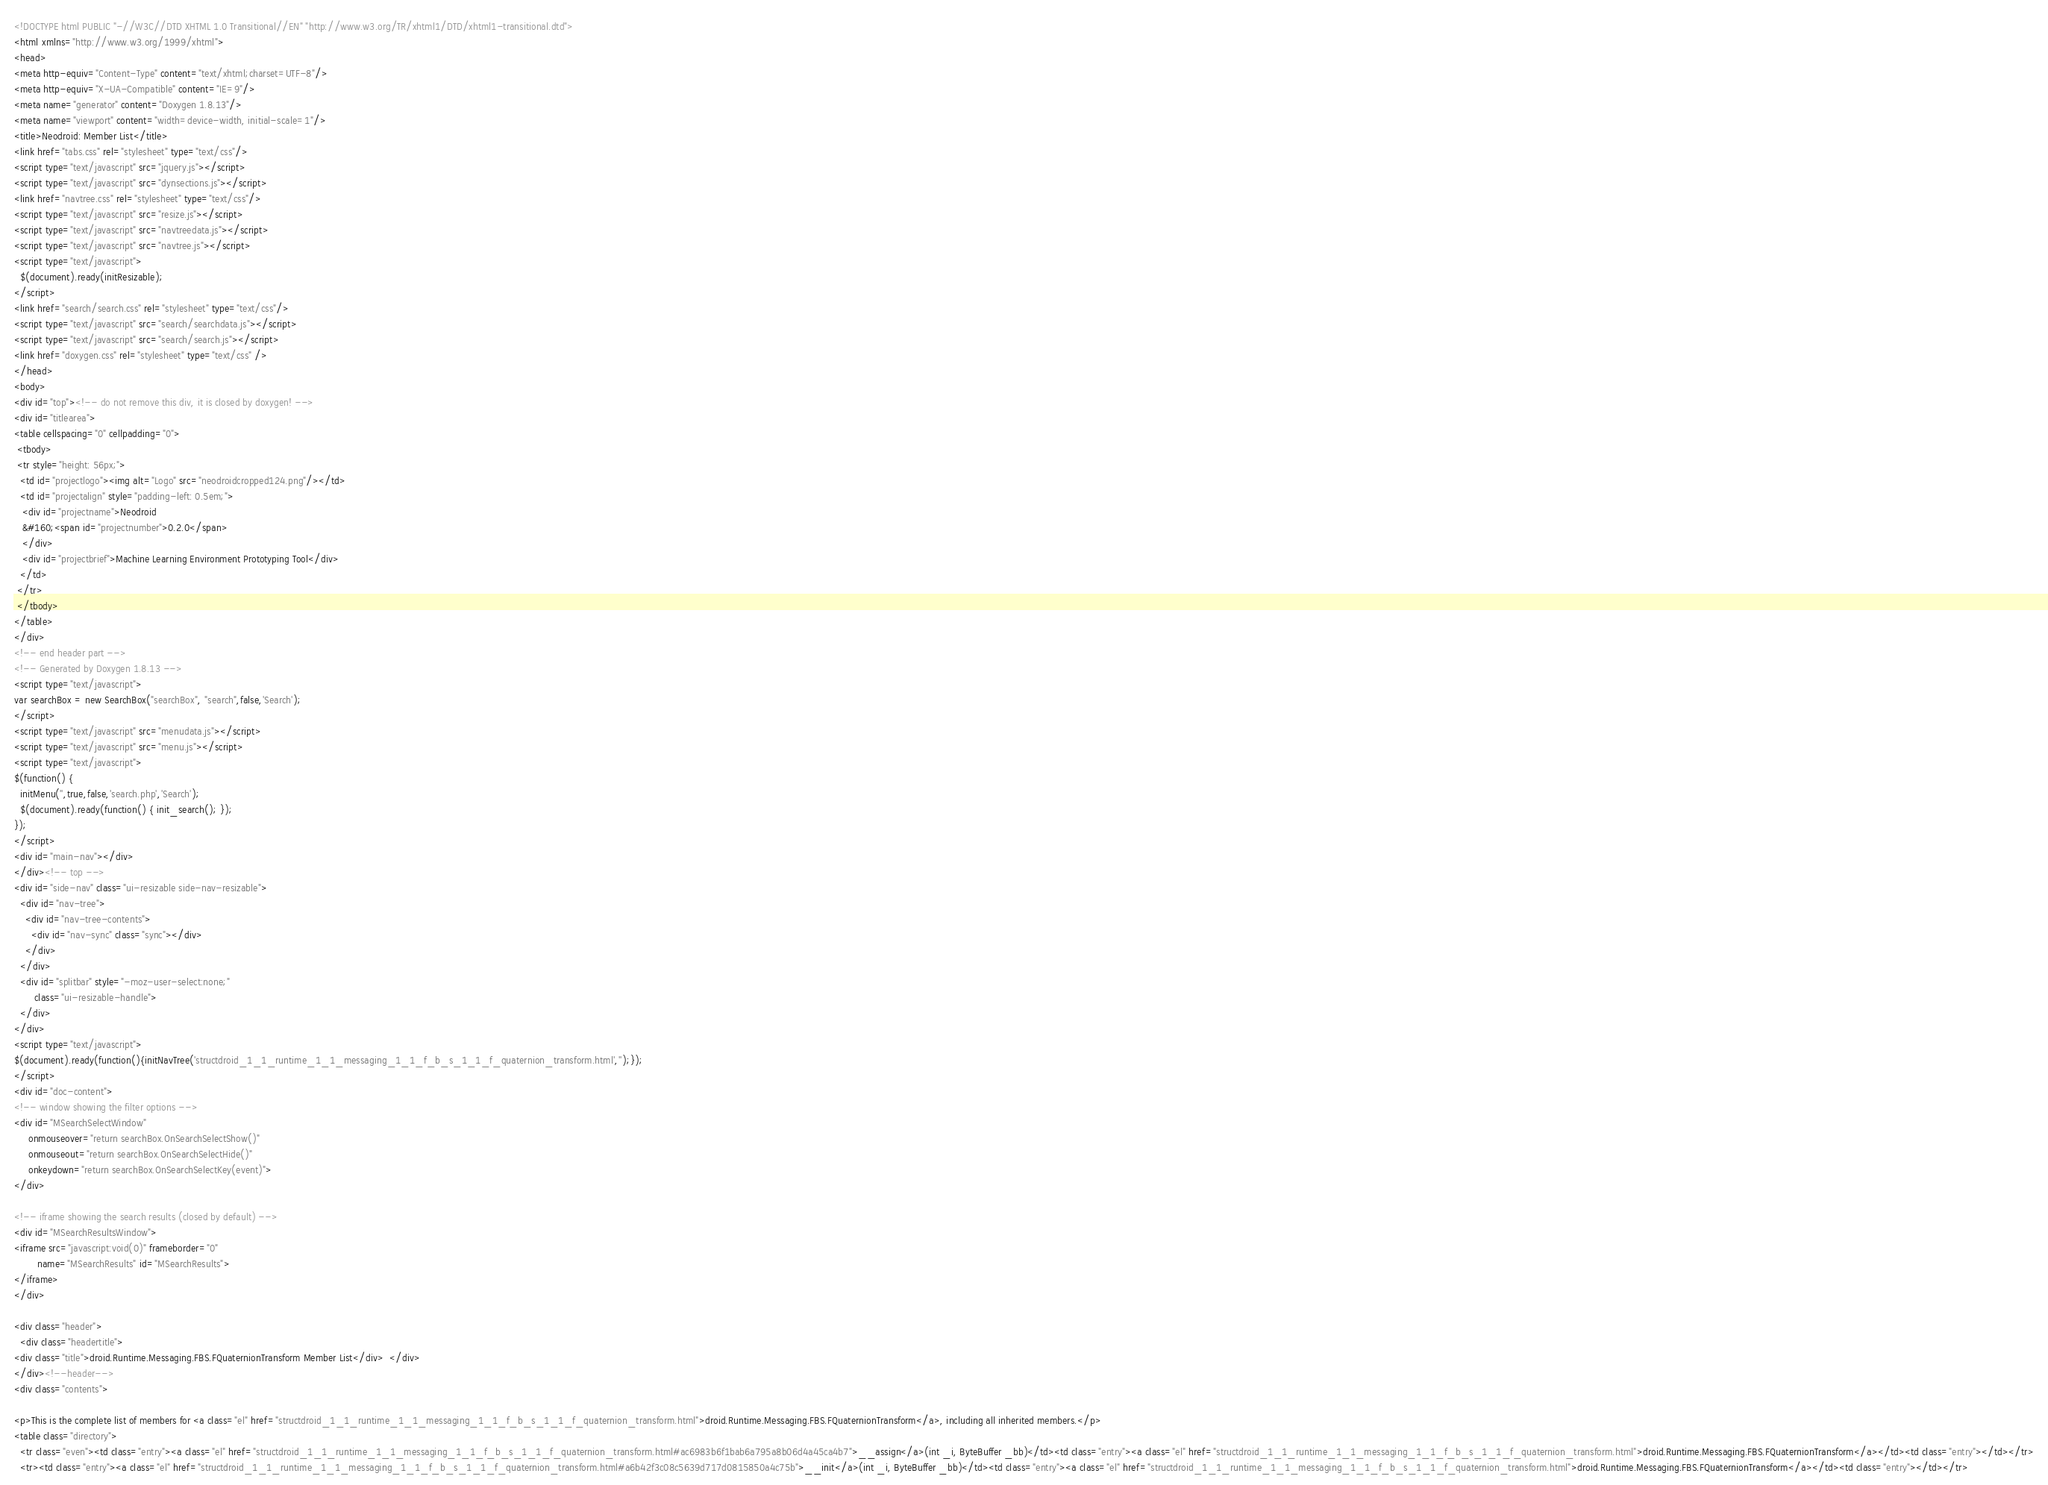Convert code to text. <code><loc_0><loc_0><loc_500><loc_500><_HTML_><!DOCTYPE html PUBLIC "-//W3C//DTD XHTML 1.0 Transitional//EN" "http://www.w3.org/TR/xhtml1/DTD/xhtml1-transitional.dtd">
<html xmlns="http://www.w3.org/1999/xhtml">
<head>
<meta http-equiv="Content-Type" content="text/xhtml;charset=UTF-8"/>
<meta http-equiv="X-UA-Compatible" content="IE=9"/>
<meta name="generator" content="Doxygen 1.8.13"/>
<meta name="viewport" content="width=device-width, initial-scale=1"/>
<title>Neodroid: Member List</title>
<link href="tabs.css" rel="stylesheet" type="text/css"/>
<script type="text/javascript" src="jquery.js"></script>
<script type="text/javascript" src="dynsections.js"></script>
<link href="navtree.css" rel="stylesheet" type="text/css"/>
<script type="text/javascript" src="resize.js"></script>
<script type="text/javascript" src="navtreedata.js"></script>
<script type="text/javascript" src="navtree.js"></script>
<script type="text/javascript">
  $(document).ready(initResizable);
</script>
<link href="search/search.css" rel="stylesheet" type="text/css"/>
<script type="text/javascript" src="search/searchdata.js"></script>
<script type="text/javascript" src="search/search.js"></script>
<link href="doxygen.css" rel="stylesheet" type="text/css" />
</head>
<body>
<div id="top"><!-- do not remove this div, it is closed by doxygen! -->
<div id="titlearea">
<table cellspacing="0" cellpadding="0">
 <tbody>
 <tr style="height: 56px;">
  <td id="projectlogo"><img alt="Logo" src="neodroidcropped124.png"/></td>
  <td id="projectalign" style="padding-left: 0.5em;">
   <div id="projectname">Neodroid
   &#160;<span id="projectnumber">0.2.0</span>
   </div>
   <div id="projectbrief">Machine Learning Environment Prototyping Tool</div>
  </td>
 </tr>
 </tbody>
</table>
</div>
<!-- end header part -->
<!-- Generated by Doxygen 1.8.13 -->
<script type="text/javascript">
var searchBox = new SearchBox("searchBox", "search",false,'Search');
</script>
<script type="text/javascript" src="menudata.js"></script>
<script type="text/javascript" src="menu.js"></script>
<script type="text/javascript">
$(function() {
  initMenu('',true,false,'search.php','Search');
  $(document).ready(function() { init_search(); });
});
</script>
<div id="main-nav"></div>
</div><!-- top -->
<div id="side-nav" class="ui-resizable side-nav-resizable">
  <div id="nav-tree">
    <div id="nav-tree-contents">
      <div id="nav-sync" class="sync"></div>
    </div>
  </div>
  <div id="splitbar" style="-moz-user-select:none;" 
       class="ui-resizable-handle">
  </div>
</div>
<script type="text/javascript">
$(document).ready(function(){initNavTree('structdroid_1_1_runtime_1_1_messaging_1_1_f_b_s_1_1_f_quaternion_transform.html','');});
</script>
<div id="doc-content">
<!-- window showing the filter options -->
<div id="MSearchSelectWindow"
     onmouseover="return searchBox.OnSearchSelectShow()"
     onmouseout="return searchBox.OnSearchSelectHide()"
     onkeydown="return searchBox.OnSearchSelectKey(event)">
</div>

<!-- iframe showing the search results (closed by default) -->
<div id="MSearchResultsWindow">
<iframe src="javascript:void(0)" frameborder="0" 
        name="MSearchResults" id="MSearchResults">
</iframe>
</div>

<div class="header">
  <div class="headertitle">
<div class="title">droid.Runtime.Messaging.FBS.FQuaternionTransform Member List</div>  </div>
</div><!--header-->
<div class="contents">

<p>This is the complete list of members for <a class="el" href="structdroid_1_1_runtime_1_1_messaging_1_1_f_b_s_1_1_f_quaternion_transform.html">droid.Runtime.Messaging.FBS.FQuaternionTransform</a>, including all inherited members.</p>
<table class="directory">
  <tr class="even"><td class="entry"><a class="el" href="structdroid_1_1_runtime_1_1_messaging_1_1_f_b_s_1_1_f_quaternion_transform.html#ac6983b6f1bab6a795a8b06d4a45ca4b7">__assign</a>(int _i, ByteBuffer _bb)</td><td class="entry"><a class="el" href="structdroid_1_1_runtime_1_1_messaging_1_1_f_b_s_1_1_f_quaternion_transform.html">droid.Runtime.Messaging.FBS.FQuaternionTransform</a></td><td class="entry"></td></tr>
  <tr><td class="entry"><a class="el" href="structdroid_1_1_runtime_1_1_messaging_1_1_f_b_s_1_1_f_quaternion_transform.html#a6b42f3c08c5639d717d0815850a4c75b">__init</a>(int _i, ByteBuffer _bb)</td><td class="entry"><a class="el" href="structdroid_1_1_runtime_1_1_messaging_1_1_f_b_s_1_1_f_quaternion_transform.html">droid.Runtime.Messaging.FBS.FQuaternionTransform</a></td><td class="entry"></td></tr></code> 